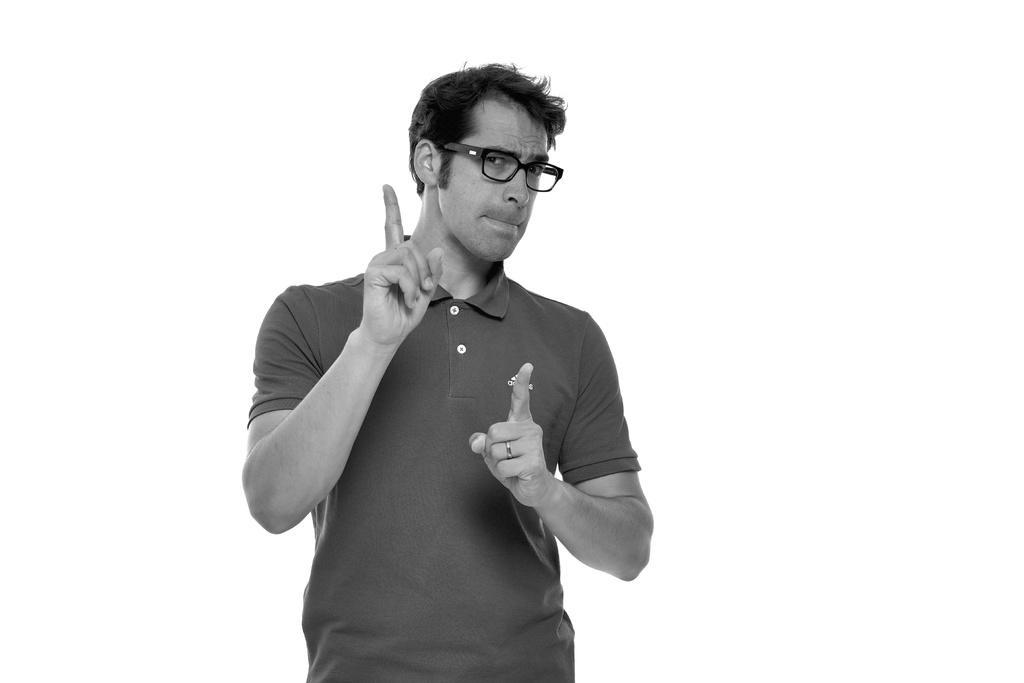Could you give a brief overview of what you see in this image? In this image we can see a person wearing spectacles. There is a white background in the image. 